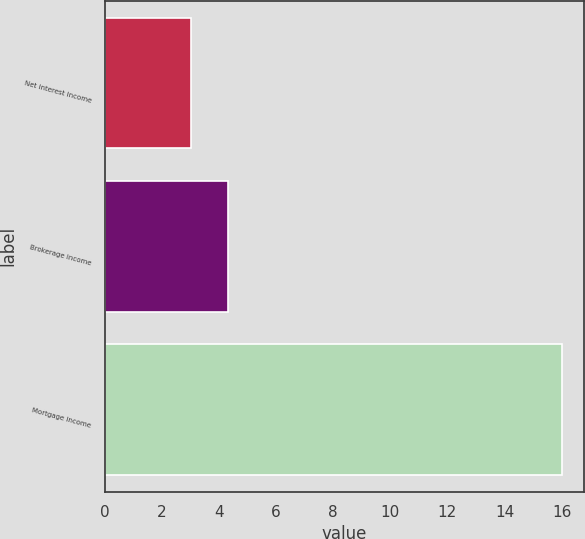Convert chart to OTSL. <chart><loc_0><loc_0><loc_500><loc_500><bar_chart><fcel>Net interest income<fcel>Brokerage income<fcel>Mortgage income<nl><fcel>3<fcel>4.3<fcel>16<nl></chart> 